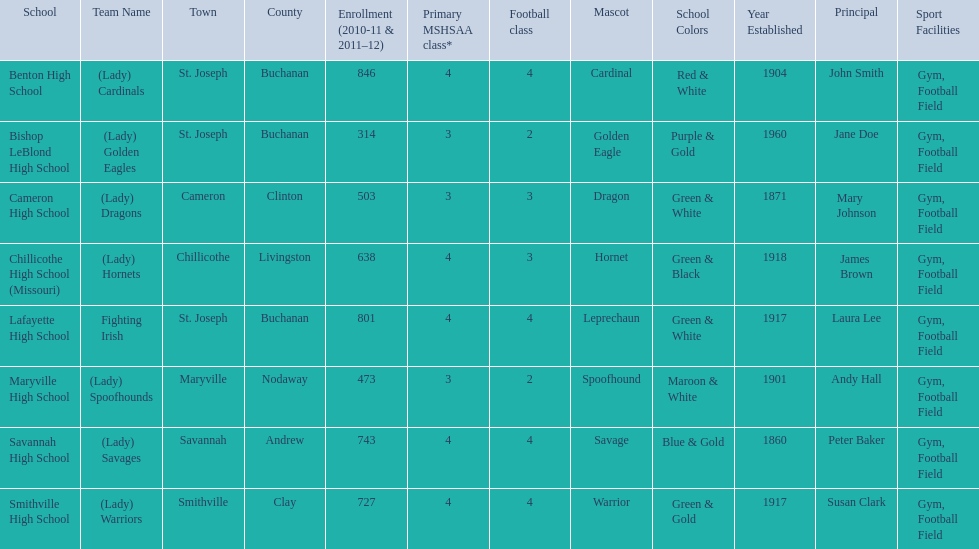How many teams are named after birds? 2. 